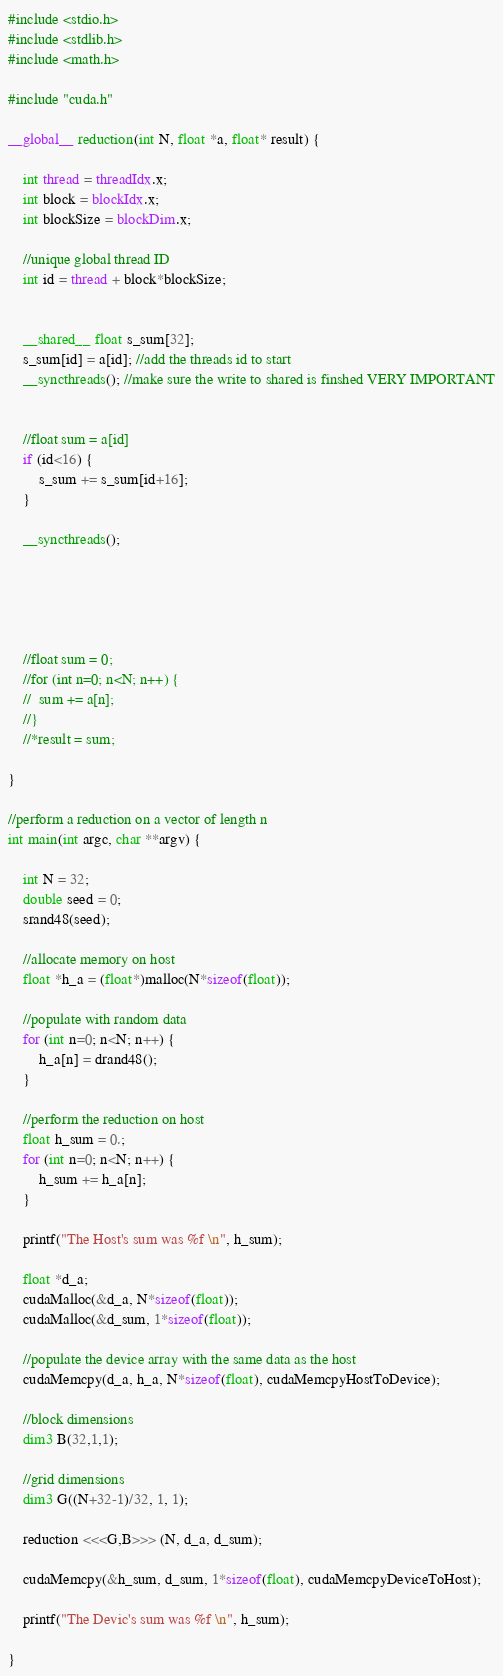<code> <loc_0><loc_0><loc_500><loc_500><_Cuda_>#include <stdio.h>
#include <stdlib.h>
#include <math.h>

#include "cuda.h"

__global__ reduction(int N, float *a, float* result) {
	
	int thread = threadIdx.x;
	int block = blockIdx.x;
	int blockSize = blockDim.x;

	//unique global thread ID
	int id = thread + block*blockSize;


	__shared__ float s_sum[32];
	s_sum[id] = a[id]; //add the threads id to start
	__syncthreads(); //make sure the write to shared is finshed VERY IMPORTANT


	//float sum = a[id]
	if (id<16) {
		s_sum += s_sum[id+16];
	}

	__syncthreads();

	



	//float sum = 0;
	//for (int n=0; n<N; n++) {
	//	sum += a[n];
	//}
	//*result = sum;

}

//perform a reduction on a vector of length n
int main(int argc, char **argv) {

	int N = 32;
	double seed = 0;
	srand48(seed);

	//allocate memory on host
	float *h_a = (float*)malloc(N*sizeof(float));

	//populate with random data
	for (int n=0; n<N; n++) {
		h_a[n] = drand48();
	}

	//perform the reduction on host
	float h_sum = 0.;
	for (int n=0; n<N; n++) {
		h_sum += h_a[n];
	}

	printf("The Host's sum was %f \n", h_sum);

	float *d_a;
	cudaMalloc(&d_a, N*sizeof(float));
	cudaMalloc(&d_sum, 1*sizeof(float));

	//populate the device array with the same data as the host
	cudaMemcpy(d_a, h_a, N*sizeof(float), cudaMemcpyHostToDevice);

	//block dimensions
	dim3 B(32,1,1);

	//grid dimensions
	dim3 G((N+32-1)/32, 1, 1);

	reduction <<<G,B>>> (N, d_a, d_sum);

	cudaMemcpy(&h_sum, d_sum, 1*sizeof(float), cudaMemcpyDeviceToHost);

	printf("The Devic's sum was %f \n", h_sum);

}
</code> 